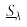Convert formula to latex. <formula><loc_0><loc_0><loc_500><loc_500>\underline { S } _ { \lambda }</formula> 